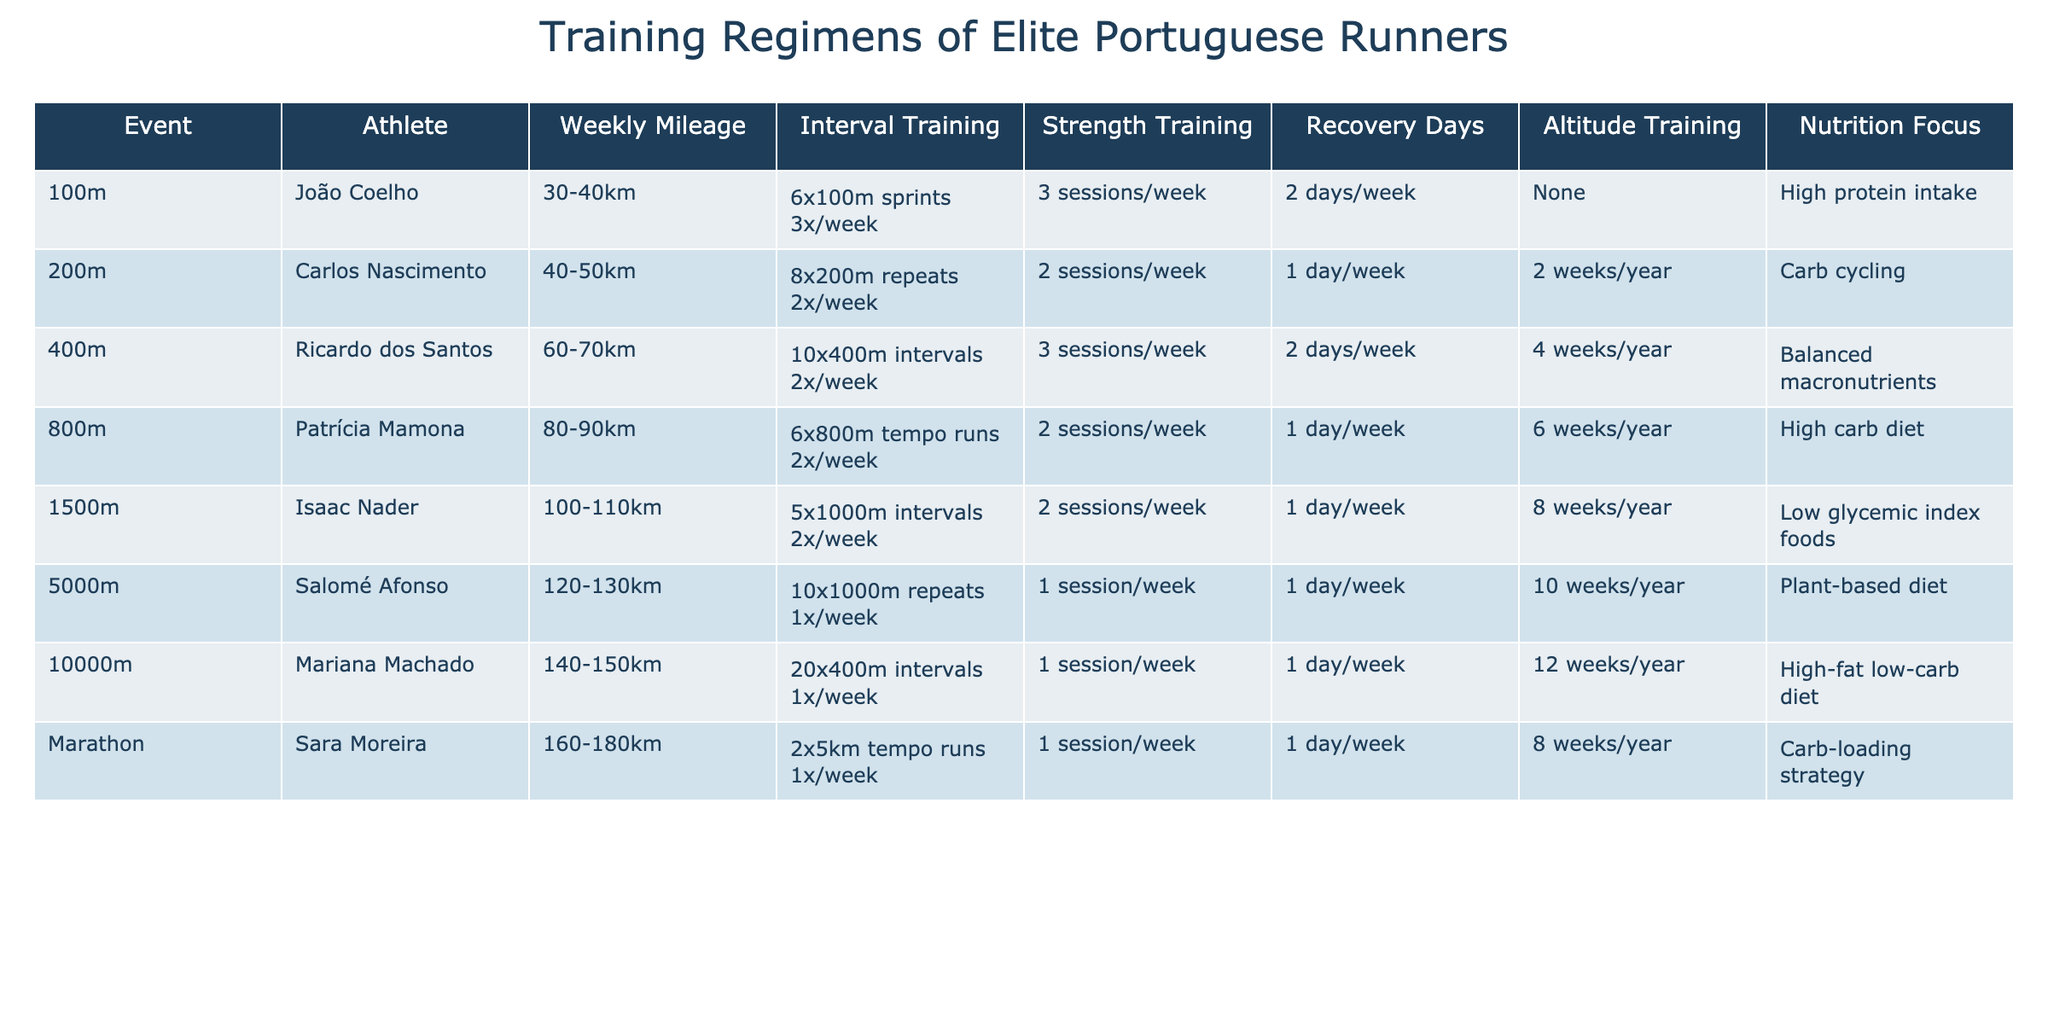What is the weekly mileage of João Coelho? The table lists the weekly mileage for João Coelho under the 100m event, which is 30-40km.
Answer: 30-40km Which athlete focuses on a balanced macronutrient diet? To find this, look under the 'Nutrition Focus' column for each athlete. Ricardo dos Santos, who runs the 400m, is associated with a balanced macronutrient diet.
Answer: Ricardo dos Santos How many times a week does Patricía Mamona do interval training? The table shows that for the 800m event, Patricía Mamona does 6x800m tempo runs 2 times per week for interval training.
Answer: 2 times What is the difference in weekly mileage between Salomé Afonso and Mariana Machado? Salomé Afonso's weekly mileage is 120-130km, and Mariana Machado's is 140-150km. The average for Salomé is 125km and for Mariana is 145km. The difference is 145 - 125 = 20km.
Answer: 20km Do any athletes focus on altitude training? Altitude training is listed for runners who compete in various events. Looking closely, João Coelho does not focus on it, but other athletes, such as Sara Moreira, have altitude training listed. Therefore, the answer is yes.
Answer: Yes Which athlete has the highest weekly mileage? By checking the 'Weekly Mileage' values in the table, Mariana Machado, who runs the 10,000m, has the highest mileage of 140-150km.
Answer: Mariana Machado What is the average number of recovery days for the athletes in this table? The recovery days are 2 (João Coelho), 1 (Carlos Nascimento), 2 (Ricardo dos Santos), 1 (Patrícia Mamona), 1 (Isaac Nader), 1 (Salomé Afonso), 1 (Mariana Machado), and 1 (Sara Moreira). Summing these gives 10 total recovery days, divided by 8 athletes equals 10/8 = 1.25 days average.
Answer: 1.25 days How many athletes have strength training sessions that occur three times per week? Checking the table under the 'Strength Training' column, João Coelho and Ricardo dos Santos both have 3 sessions per week, totaling 2 athletes.
Answer: 2 athletes Which event has the lowest weekly mileage? The 100m event (João Coelho) has the lowest range of weekly mileage at 30-40km as compared to the other events listed.
Answer: 100m event What type of diet does the athlete running the marathon follow? By checking the table under the marathon event, Sara Moreira follows a carb-loading strategy.
Answer: Carb-loading strategy 